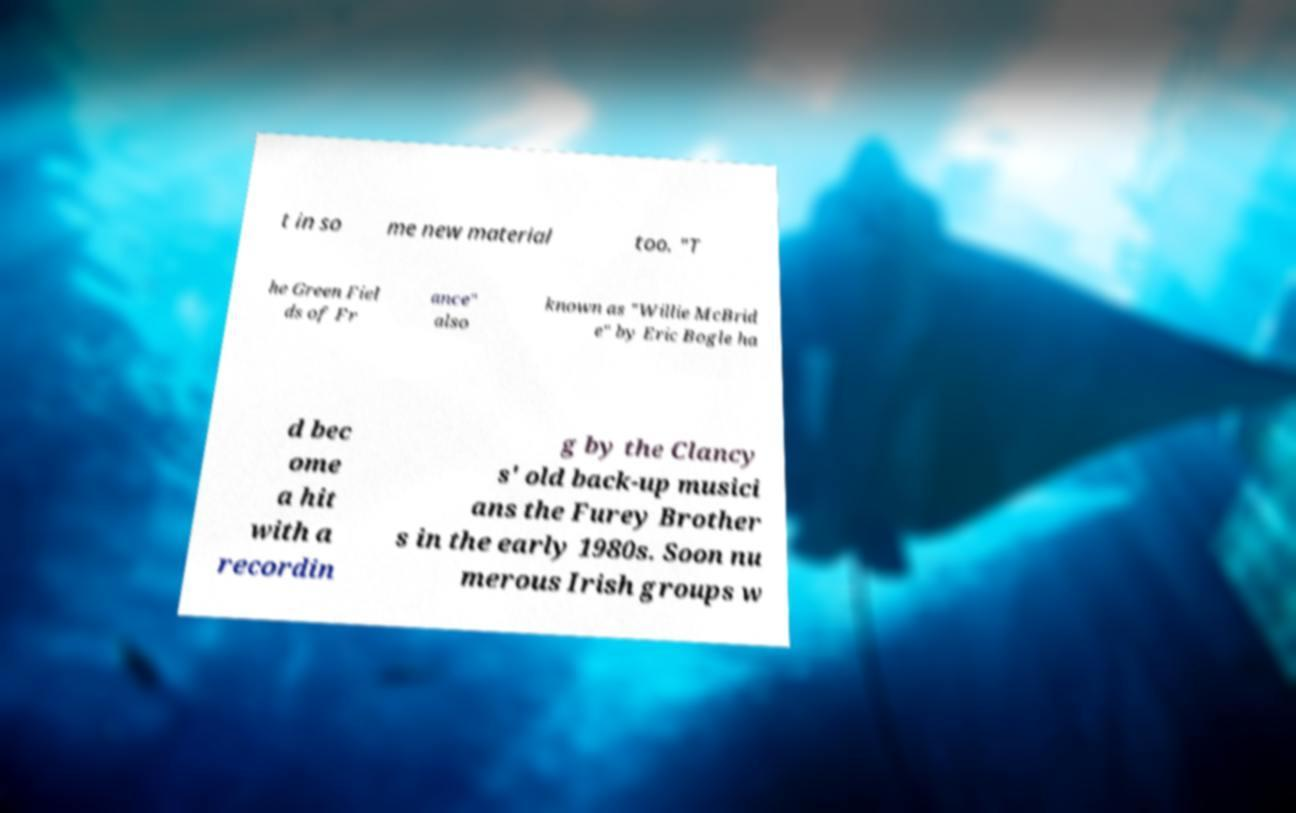Could you assist in decoding the text presented in this image and type it out clearly? t in so me new material too. "T he Green Fiel ds of Fr ance" also known as "Willie McBrid e" by Eric Bogle ha d bec ome a hit with a recordin g by the Clancy s' old back-up musici ans the Furey Brother s in the early 1980s. Soon nu merous Irish groups w 